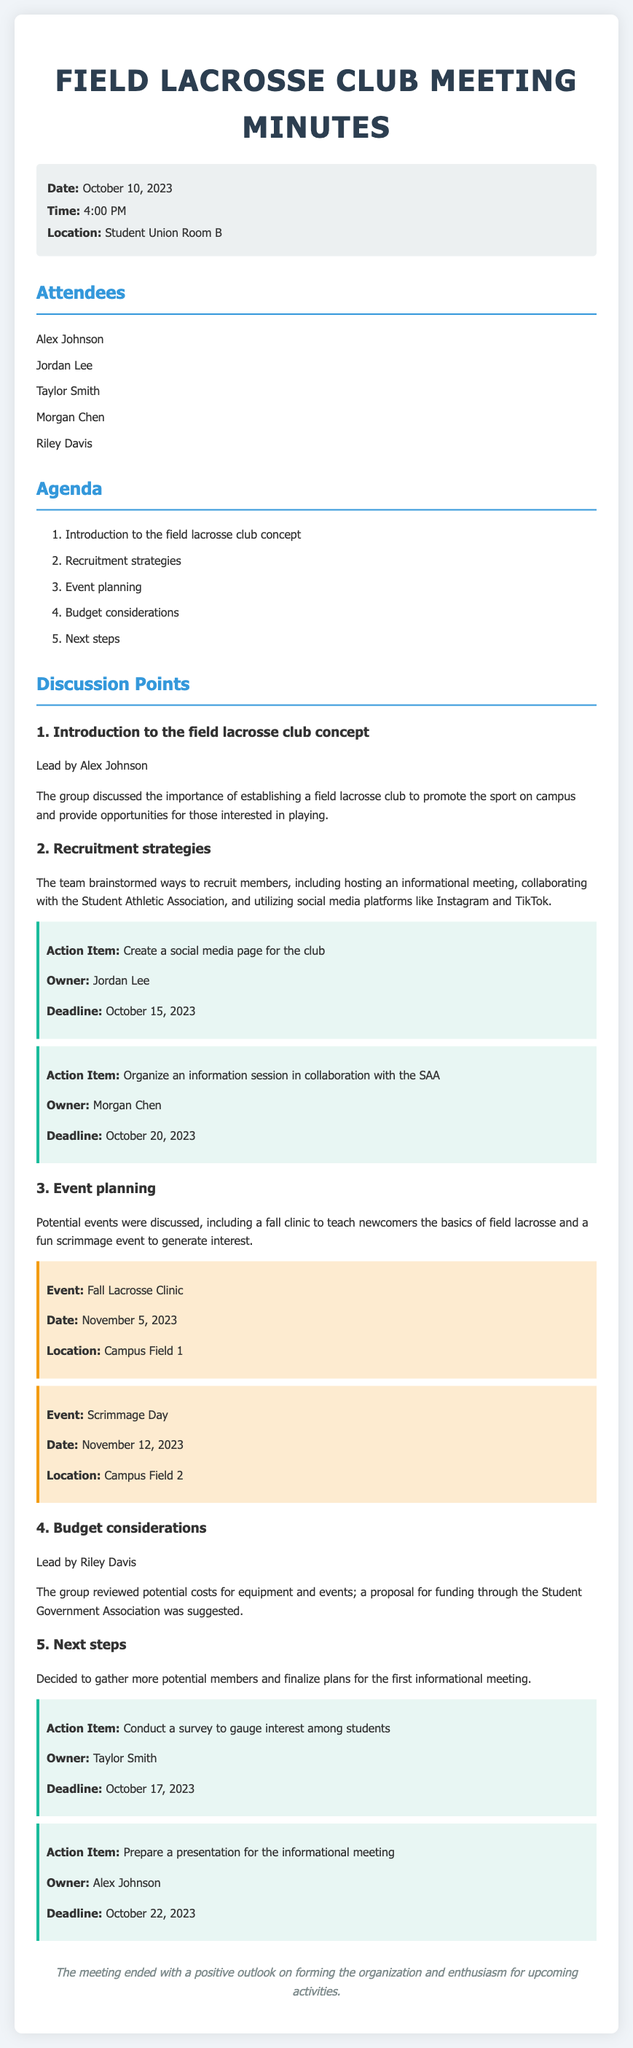What is the date of the meeting? The date of the meeting is provided in the info block at the top of the document.
Answer: October 10, 2023 Who led the discussion on the budget considerations? The leader of the budget discussion is specified in the discussion points section.
Answer: Riley Davis What is the deadline for creating a social media page for the club? The deadline for the action item about the social media page is included in the action item details.
Answer: October 15, 2023 What event is scheduled for November 5, 2023? The event details include specific information about the planned activities, including the date and event name.
Answer: Fall Lacrosse Clinic How many attendees were present at the meeting? The number of attendees can be counted from the list given in the attendees section.
Answer: Five attendees What are the two recruitment strategies mentioned? The recruitment strategies include methods discussed during the brainstorming portion about growing club membership.
Answer: Informational meeting, collaborating with the Student Athletic Association What is the main objective of establishing the field lacrosse club? The purpose for establishing the club is included in the introduction discussion.
Answer: Promote the sport on campus What is the location for the scrimmage day event? The location is indicated in the event section with the relevant event date.
Answer: Campus Field 2 What action item is assigned to Taylor Smith? The specific action item details and ownership can be found within the action items listed in the meeting minutes.
Answer: Conduct a survey to gauge interest among students 